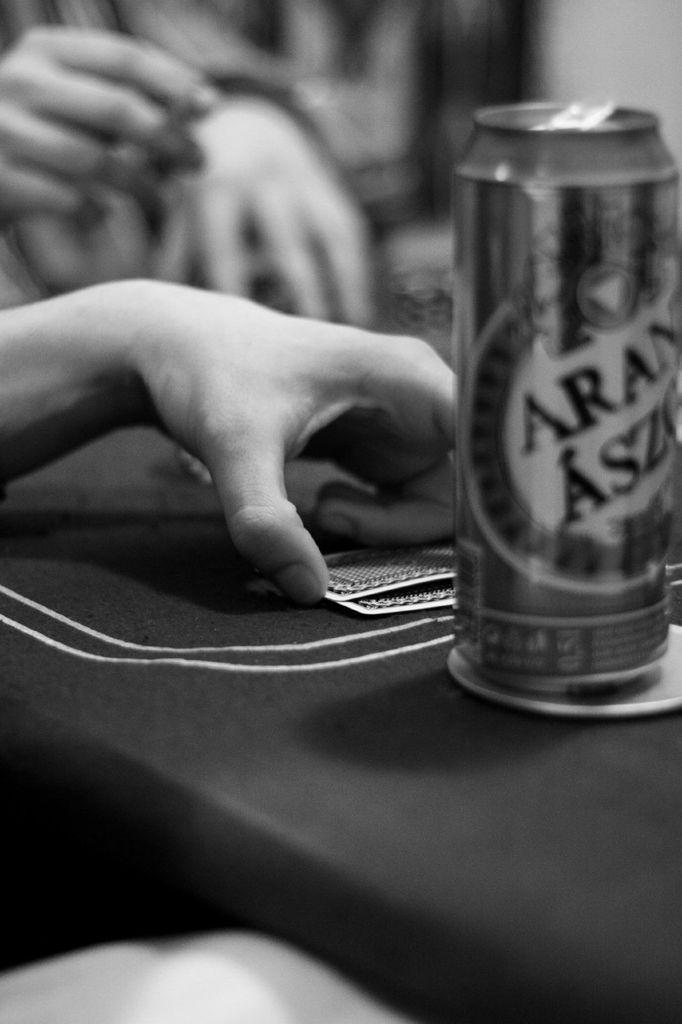Describe this image in one or two sentences. In the image we can see human hand, two cards, cane and the background is blurred. 